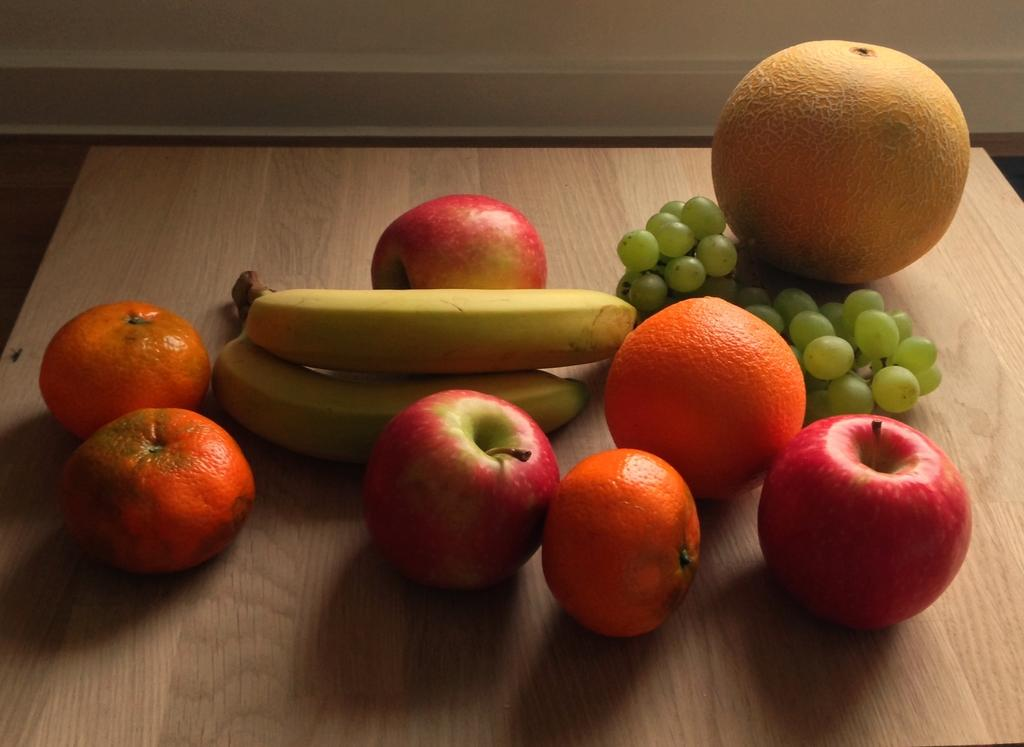What type of food can be seen on the table in the image? There are fruits on the table in the image. Can you name some specific fruits that are visible? Some of the fruits are apples, oranges, bananas, and grapes. Is there a body lying on the table among the fruits in the image? No, there is no body present in the image; it only features fruits on the table. 